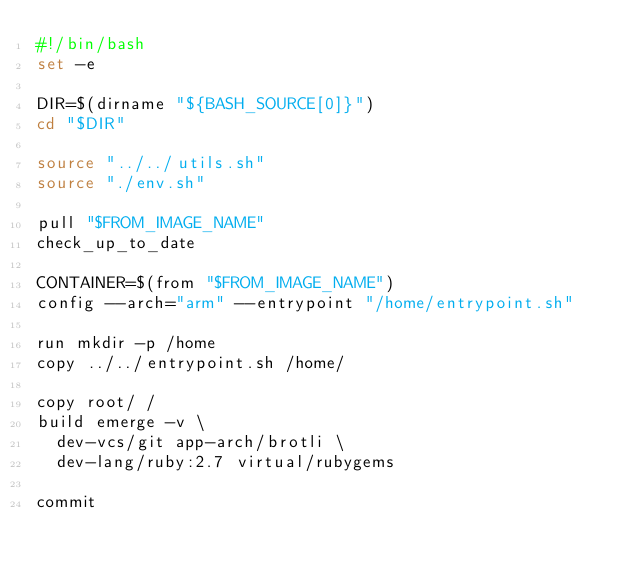<code> <loc_0><loc_0><loc_500><loc_500><_Bash_>#!/bin/bash
set -e

DIR=$(dirname "${BASH_SOURCE[0]}")
cd "$DIR"

source "../../utils.sh"
source "./env.sh"

pull "$FROM_IMAGE_NAME"
check_up_to_date

CONTAINER=$(from "$FROM_IMAGE_NAME")
config --arch="arm" --entrypoint "/home/entrypoint.sh"

run mkdir -p /home
copy ../../entrypoint.sh /home/

copy root/ /
build emerge -v \
  dev-vcs/git app-arch/brotli \
  dev-lang/ruby:2.7 virtual/rubygems

commit
</code> 